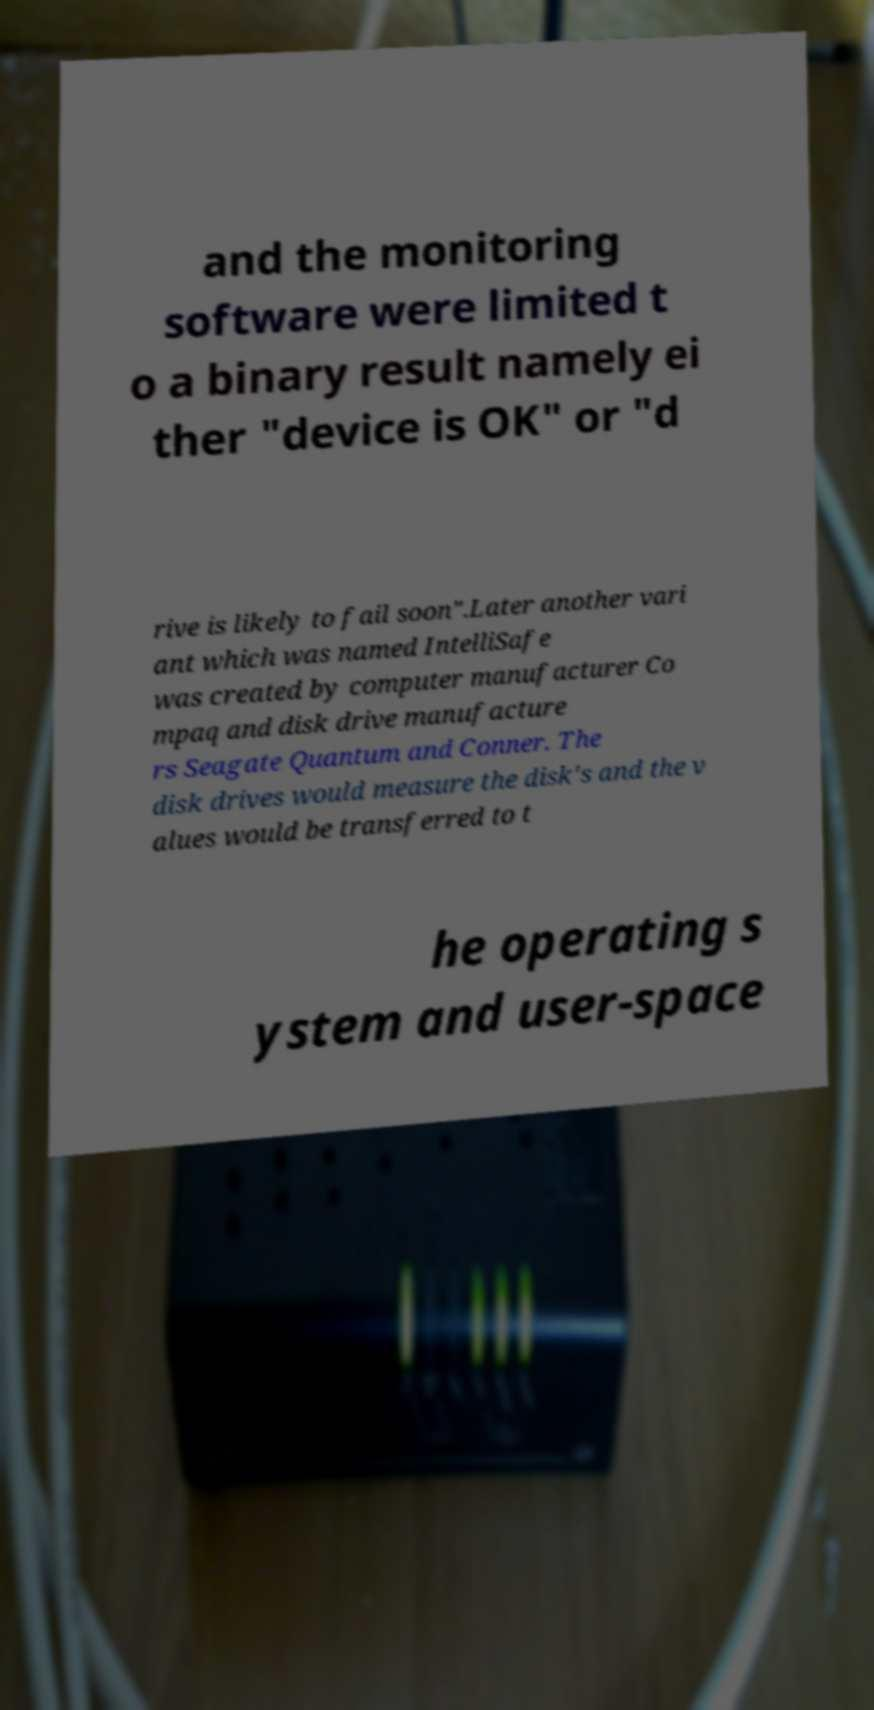I need the written content from this picture converted into text. Can you do that? and the monitoring software were limited t o a binary result namely ei ther "device is OK" or "d rive is likely to fail soon".Later another vari ant which was named IntelliSafe was created by computer manufacturer Co mpaq and disk drive manufacture rs Seagate Quantum and Conner. The disk drives would measure the disk's and the v alues would be transferred to t he operating s ystem and user-space 